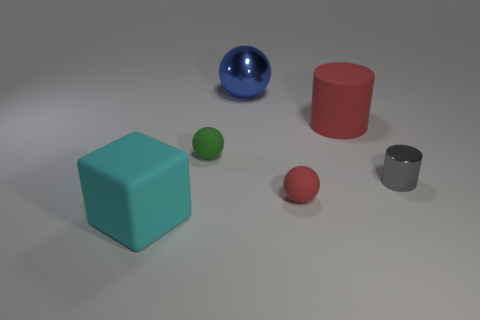Subtract all large metal spheres. How many spheres are left? 2 Add 1 cyan matte objects. How many objects exist? 7 Subtract all blocks. How many objects are left? 5 Subtract 0 green cylinders. How many objects are left? 6 Subtract all small purple matte things. Subtract all gray things. How many objects are left? 5 Add 5 tiny balls. How many tiny balls are left? 7 Add 2 matte cubes. How many matte cubes exist? 3 